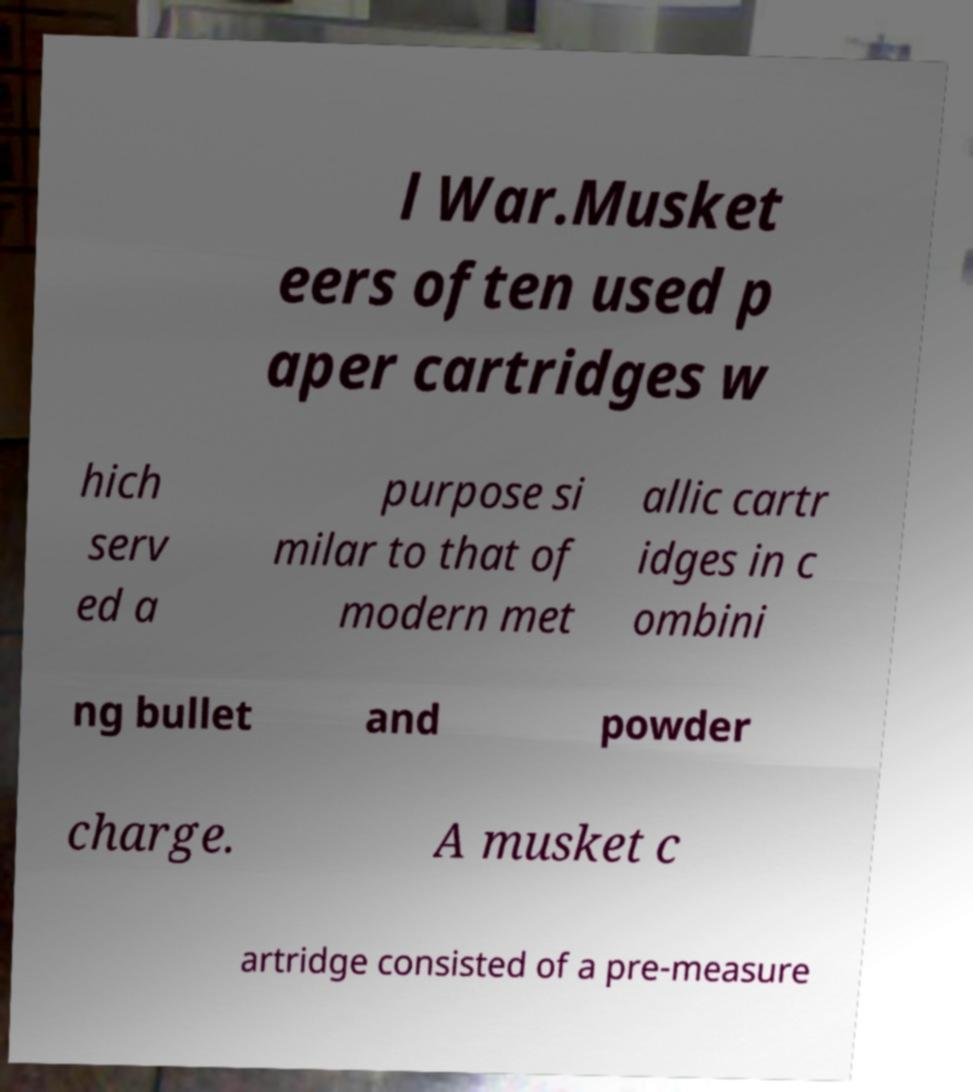What messages or text are displayed in this image? I need them in a readable, typed format. l War.Musket eers often used p aper cartridges w hich serv ed a purpose si milar to that of modern met allic cartr idges in c ombini ng bullet and powder charge. A musket c artridge consisted of a pre-measure 